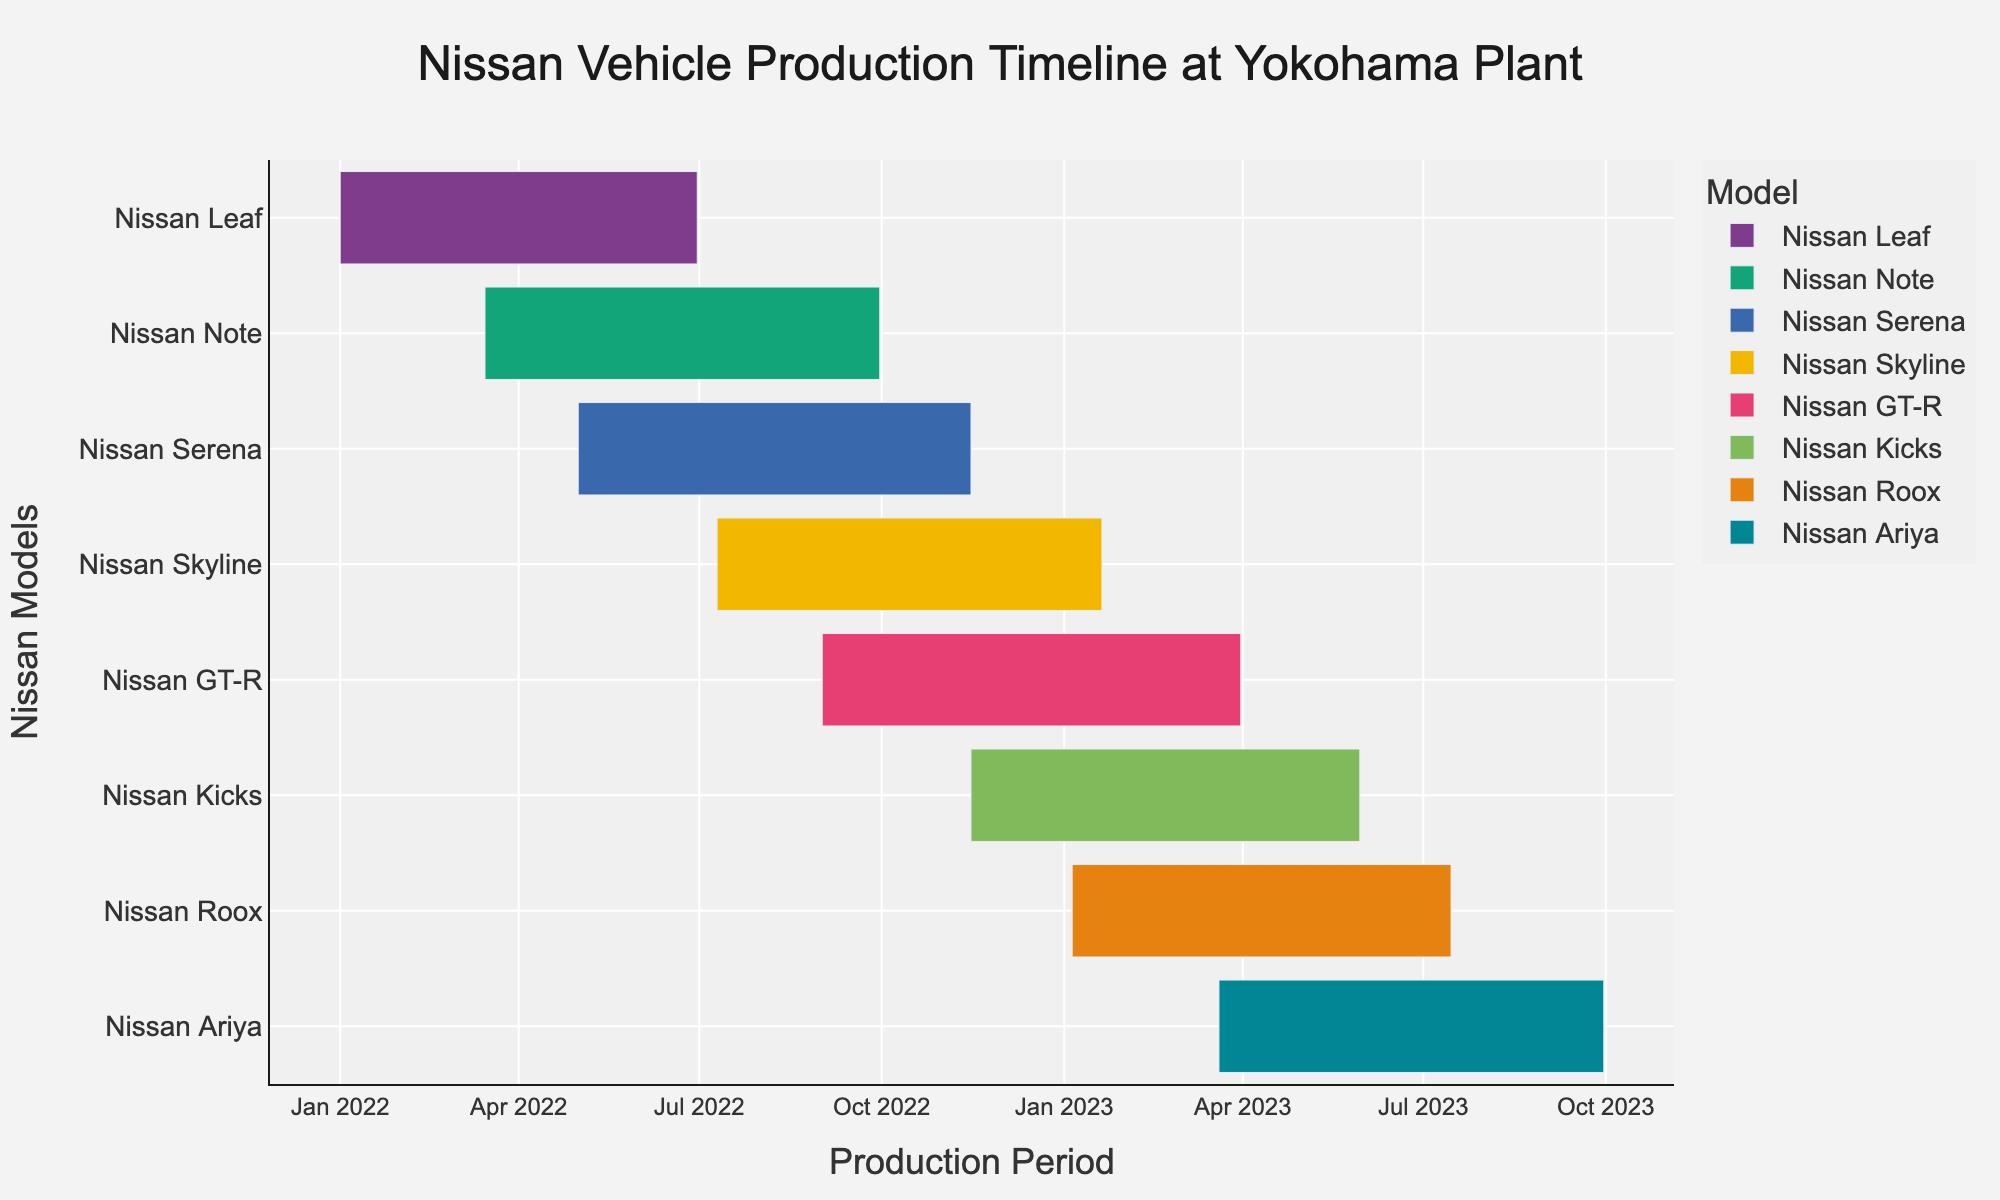How many Nissan models are included in the production timeline? Count the number of unique Nissan models listed on the Y-axis of the Gantt chart. There are eight unique models: Nissan Leaf, Nissan Note, Nissan Serena, Nissan Skyline, Nissan GT-R, Nissan Kicks, Nissan Roox, and Nissan Ariya.
Answer: 8 Which Nissan model had the earliest production start date? Identify the model with the earliest start date by referring to the start dates on the X-axis. Nissan Leaf has the earliest start date, January 1, 2022.
Answer: Nissan Leaf During which months was the Nissan Note being produced? Look at the production period bar for the Nissan Note and note the start and end dates. Nissan Note was produced from March 15, 2022, to September 30, 2022.
Answer: March to September 2022 Which two models had overlapping production periods in May 2022? Check the production period bars on the timeline and identify models with overlapping bars in May 2022. Nissan Note and Nissan Serena had overlapping production periods in May 2022.
Answer: Nissan Note and Nissan Serena What is the total duration of the production for the Nissan GT-R? Calculate the difference between the start and end dates for the Nissan GT-R's production period. The Nissan GT-R was produced from September 1, 2022, to March 31, 2023, which is 212 days.
Answer: 212 days Which Nissan model had the longest production duration? Compare the production durations of all models by checking the length of each production period bar. The Nissan Roox had the longest production duration from January 5, 2023, to July 15, 2023.
Answer: Nissan Roox Did the production of the Nissan Skyline and Nissan Ariya overlap? Examine the production periods of Nissan Skyline and Nissan Ariya to see if their bars intersect. The Nissan Skyline was produced from July 10, 2022, to January 20, 2023, and the Nissan Ariya from March 20, 2023, to September 30, 2023. Their production periods did not overlap.
Answer: No Which model was produced immediately after the Nissan Leaf's production ended? Find the end date of Nissan Leaf's production and identify the model whose production started immediately after it. The Nissan Leaf's production ended on June 30, 2022, and Nissan Note started on March 15, 2022, overlapping but not immediately succeeding. For the next unique start, Nissan Serena started on May 1, 2022.
Answer: Nissan Serena How many models were in production during December 2022? Check which models' production periods include December 2022 by referring to the X-axis timeline. Nissan Note, Nissan Serena, Nissan Skyline, and Nissan GT-R were in production during December 2022.
Answer: 4 models 